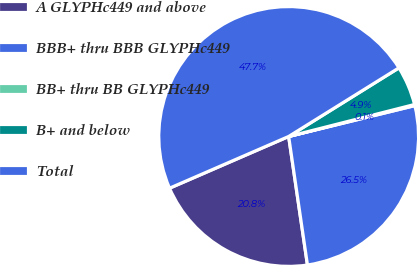Convert chart. <chart><loc_0><loc_0><loc_500><loc_500><pie_chart><fcel>A GLYPHc449 and above<fcel>BBB+ thru BBB GLYPHc449<fcel>BB+ thru BB GLYPHc449<fcel>B+ and below<fcel>Total<nl><fcel>20.79%<fcel>26.51%<fcel>0.14%<fcel>4.9%<fcel>47.66%<nl></chart> 